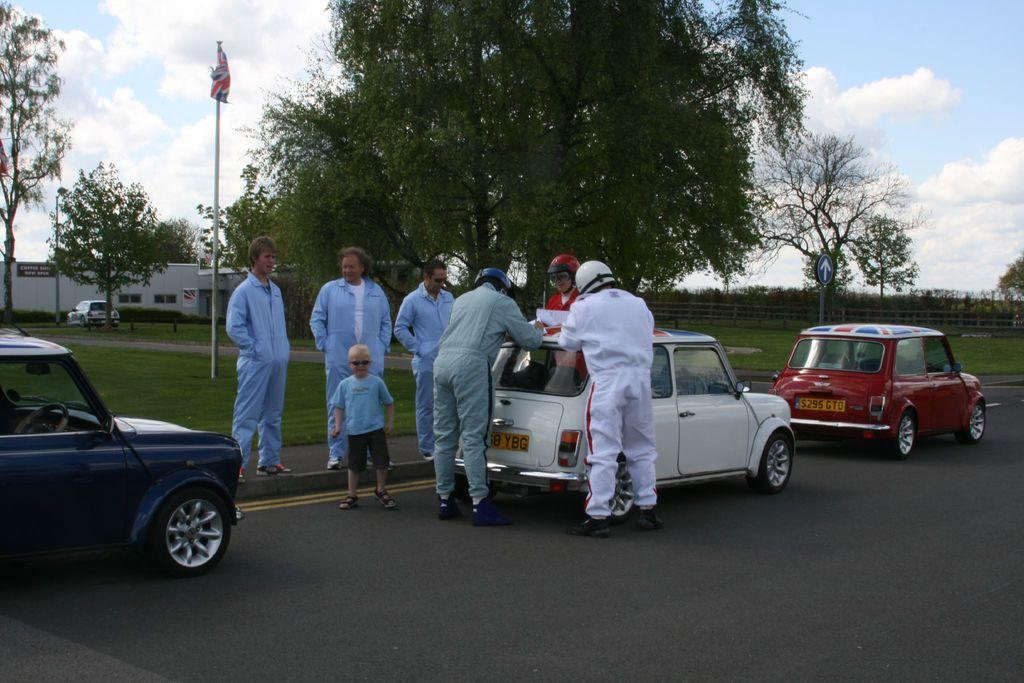What types of objects can be seen in the image? There are vehicles, poles, a flag, a sign board, a fence, houses, and trees in the image. Are there any people present in the image? Yes, there are people on the road in the image. What can be seen in the background of the image? The sky is visible in the background of the image. What type of cabbage is being used as a decoration on the flag in the image? There is no cabbage present in the image, and the flag does not have any decorations. How does the love between the people on the road in the image manifest itself? The image does not depict any emotions or relationships between the people, so it is not possible to determine how love might manifest itself. 